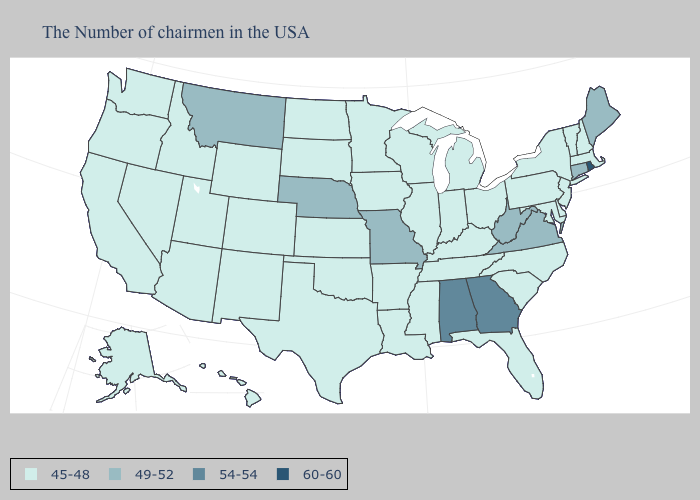What is the lowest value in states that border Maryland?
Concise answer only. 45-48. Does Hawaii have the same value as New Mexico?
Keep it brief. Yes. Among the states that border Virginia , which have the lowest value?
Quick response, please. Maryland, North Carolina, Kentucky, Tennessee. Does West Virginia have the highest value in the USA?
Quick response, please. No. What is the value of New Hampshire?
Quick response, please. 45-48. Name the states that have a value in the range 60-60?
Be succinct. Rhode Island. What is the highest value in the MidWest ?
Answer briefly. 49-52. Among the states that border South Dakota , which have the highest value?
Quick response, please. Nebraska, Montana. What is the highest value in the South ?
Quick response, please. 54-54. Does the first symbol in the legend represent the smallest category?
Give a very brief answer. Yes. Does Arkansas have a lower value than Connecticut?
Write a very short answer. Yes. What is the highest value in the West ?
Concise answer only. 49-52. What is the highest value in states that border Louisiana?
Write a very short answer. 45-48. 